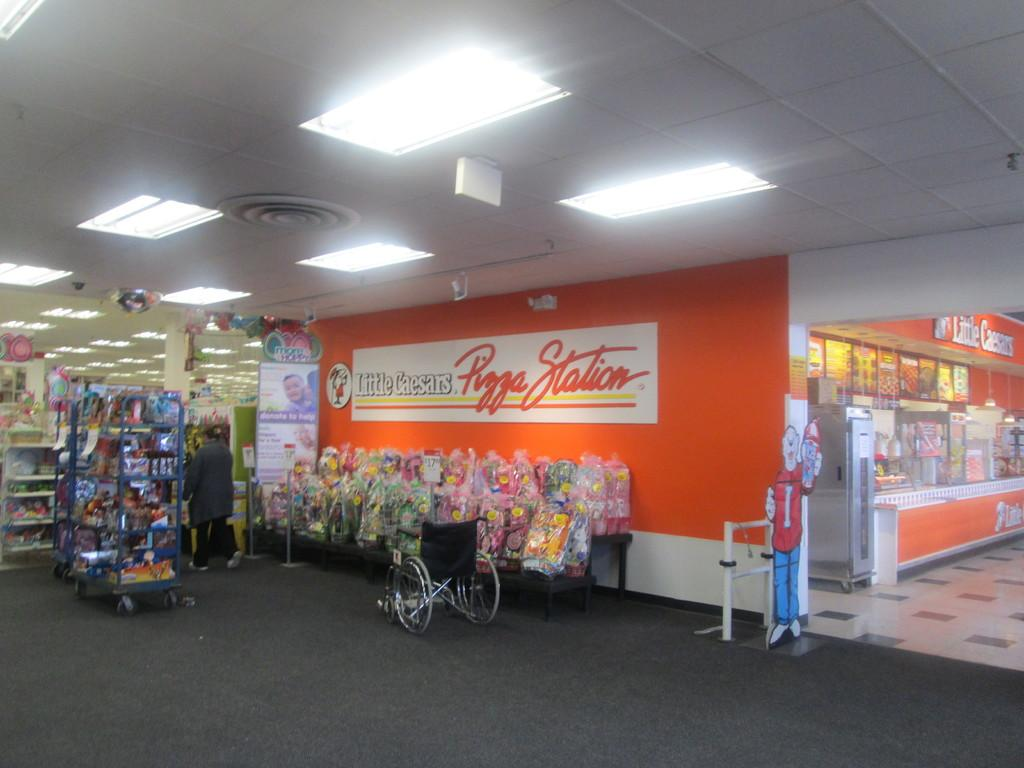<image>
Offer a succinct explanation of the picture presented. Little Caesar's Pizza Station entrance is connected to another store. 